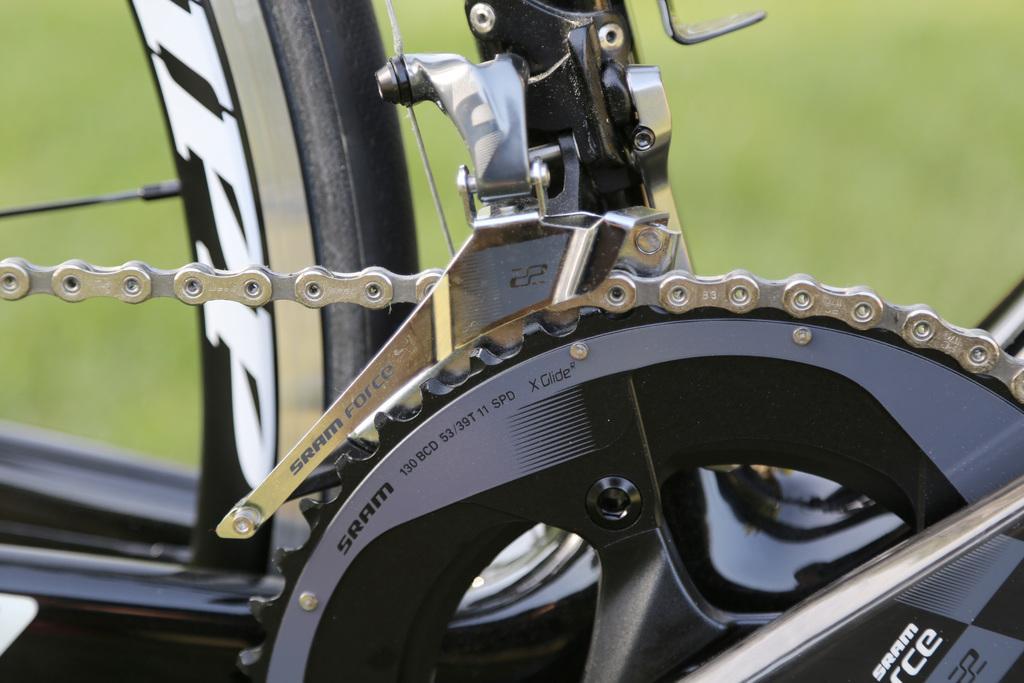How would you summarize this image in a sentence or two? In this image there is a bicycle having a metal chain and a metal wheel. Background is blurry. 